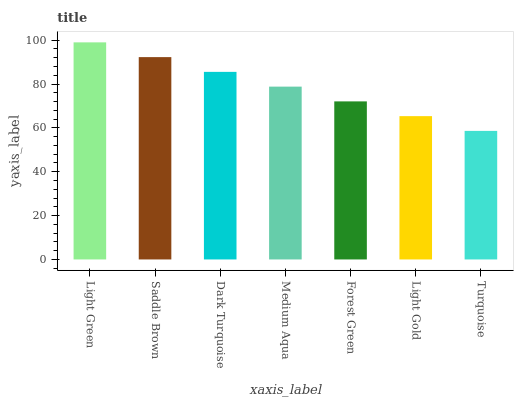Is Turquoise the minimum?
Answer yes or no. Yes. Is Light Green the maximum?
Answer yes or no. Yes. Is Saddle Brown the minimum?
Answer yes or no. No. Is Saddle Brown the maximum?
Answer yes or no. No. Is Light Green greater than Saddle Brown?
Answer yes or no. Yes. Is Saddle Brown less than Light Green?
Answer yes or no. Yes. Is Saddle Brown greater than Light Green?
Answer yes or no. No. Is Light Green less than Saddle Brown?
Answer yes or no. No. Is Medium Aqua the high median?
Answer yes or no. Yes. Is Medium Aqua the low median?
Answer yes or no. Yes. Is Turquoise the high median?
Answer yes or no. No. Is Dark Turquoise the low median?
Answer yes or no. No. 